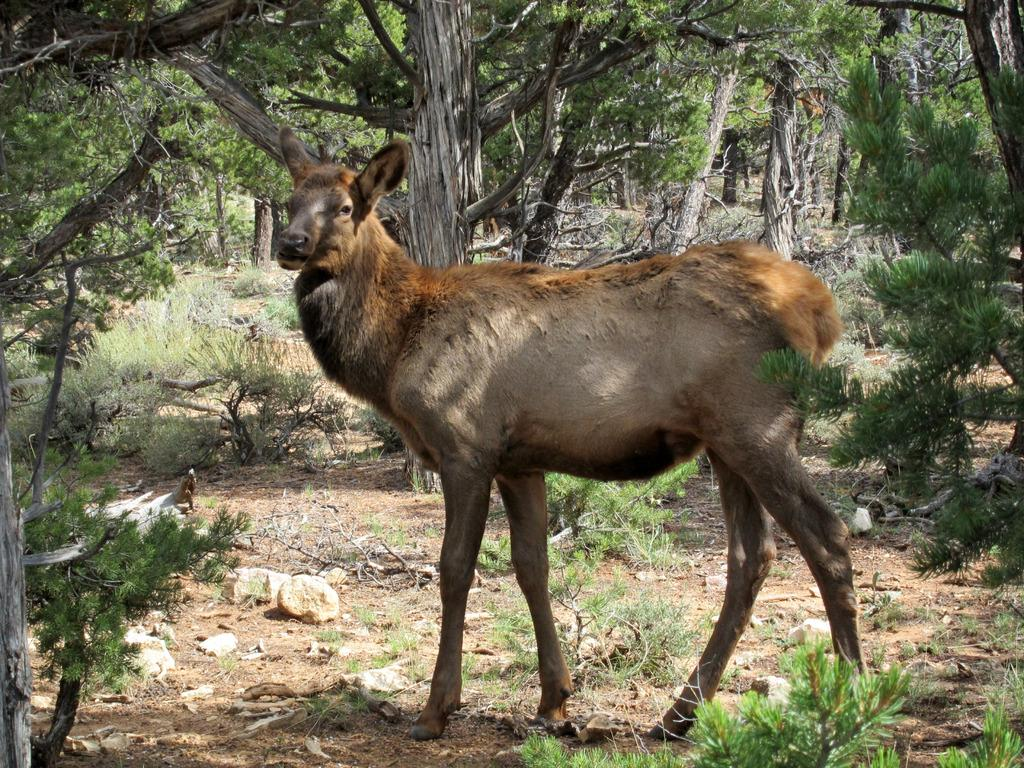What animal is the main subject of the image? There is a deer in the image. What type of environment is the deer in? There are many trees around the deer in the image. Can you see any waves in the image? There are no waves present in the image; it features a deer in a forested area. Is the deer positioned low in the image? The position of the deer in the image cannot be determined based on the provided facts, as there is no information about its height or elevation. 